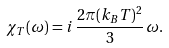<formula> <loc_0><loc_0><loc_500><loc_500>\chi _ { T } ( \omega ) = i \, \frac { 2 \pi ( k _ { B } T ) ^ { 2 } } { 3 } \, \omega .</formula> 